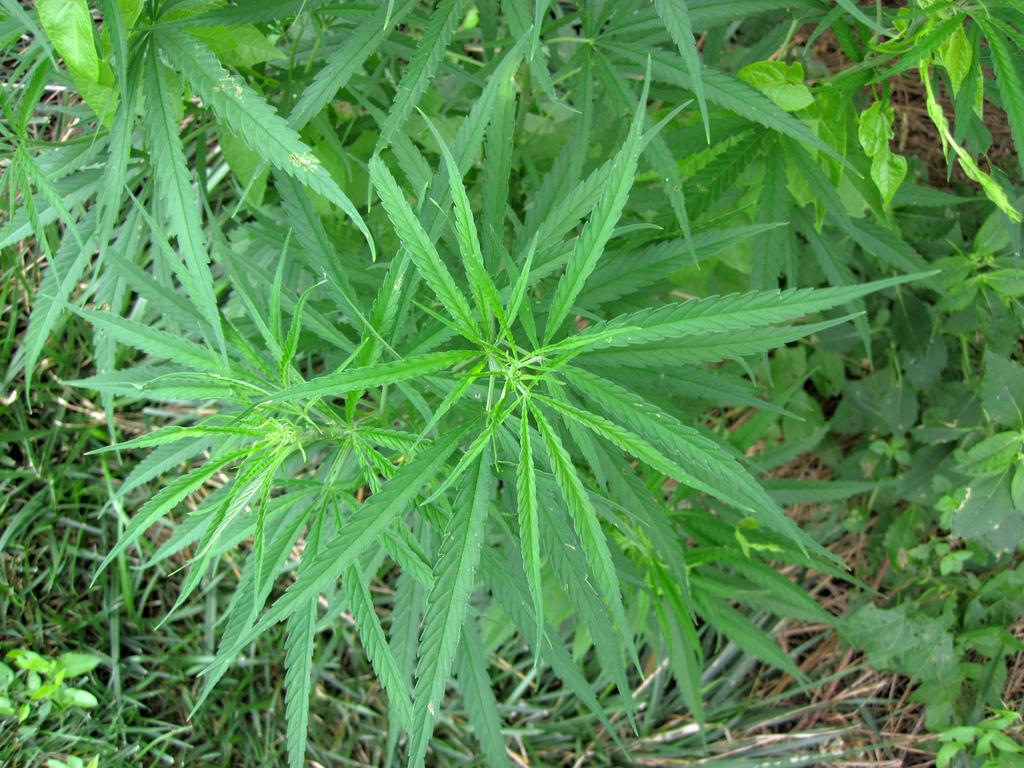What type of vegetation can be seen in the image? There are trees in the image. What is covering the ground in the image? There is grass on the ground in the image. Where is the vase located in the image? There is no vase present in the image. Can you tell me how many pigs are visible in the image? There are no pigs visible in the image. 